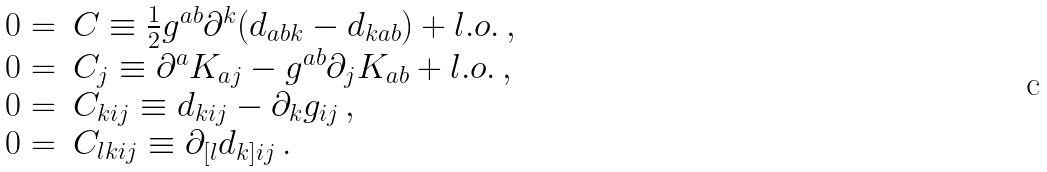<formula> <loc_0><loc_0><loc_500><loc_500>\begin{array} { r l l } 0 = & C \equiv \frac { 1 } { 2 } g ^ { a b } \partial ^ { k } ( d _ { a b k } - d _ { k a b } ) + l . o . \, , & \\ 0 = & C _ { j } \equiv \partial ^ { a } K _ { a j } - g ^ { a b } \partial _ { j } K _ { a b } + l . o . \, , & \\ 0 = & C _ { k i j } \equiv d _ { k i j } - \partial _ { k } g _ { i j } \, , & \\ 0 = & C _ { l k i j } \equiv \partial _ { [ l } d _ { k ] i j } \, . & \ \end{array}</formula> 